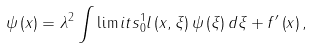<formula> <loc_0><loc_0><loc_500><loc_500>\psi \left ( x \right ) = \lambda ^ { 2 } \int \lim i t s _ { 0 } ^ { 1 } l \left ( x , \xi \right ) \psi \left ( \xi \right ) d \xi + f ^ { \prime } \left ( x \right ) ,</formula> 